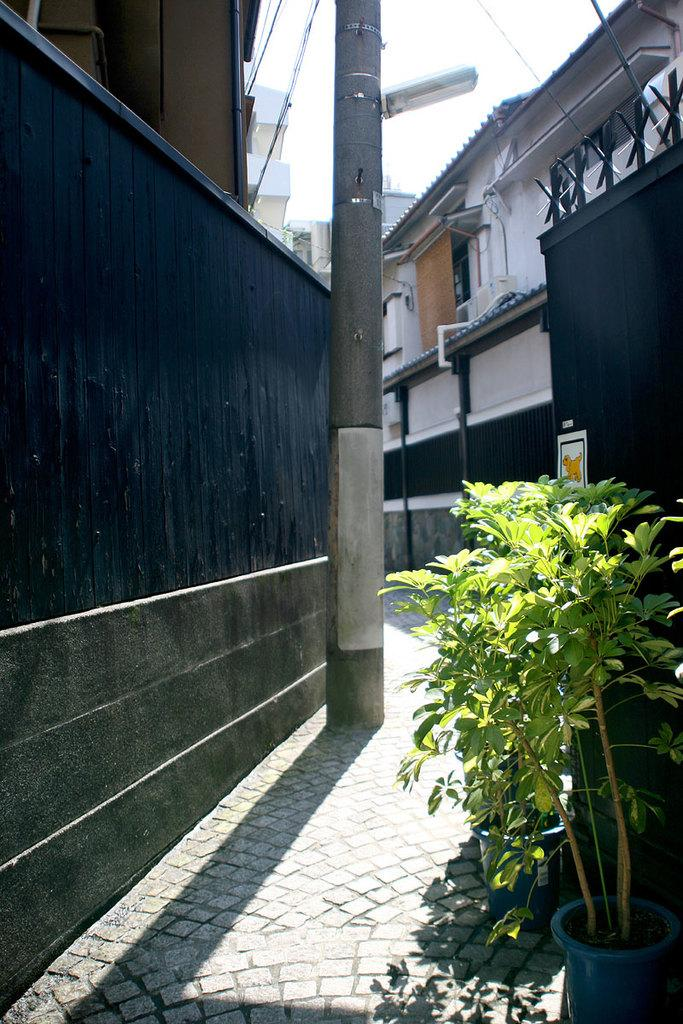What type of structures can be seen in the image? There are buildings in the image. Are there any natural elements present in the image? Yes, there is a plant in the image. What type of leather can be seen on the plant in the image? There is no leather present in the image, as it features buildings and a plant. 